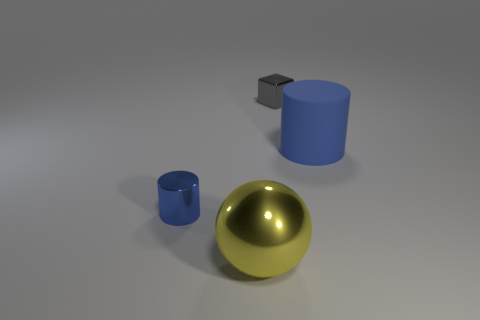Add 2 big cylinders. How many objects exist? 6 Subtract all cubes. How many objects are left? 3 Add 2 blue cylinders. How many blue cylinders are left? 4 Add 3 big red cylinders. How many big red cylinders exist? 3 Subtract 0 gray spheres. How many objects are left? 4 Subtract all blue spheres. Subtract all yellow objects. How many objects are left? 3 